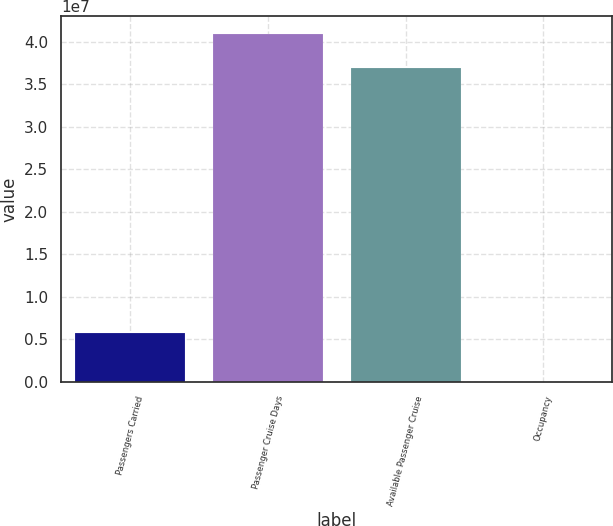<chart> <loc_0><loc_0><loc_500><loc_500><bar_chart><fcel>Passengers Carried<fcel>Passenger Cruise Days<fcel>Available Passenger Cruise<fcel>Occupancy<nl><fcel>5.7685e+06<fcel>4.09343e+07<fcel>3.69309e+07<fcel>108.4<nl></chart> 